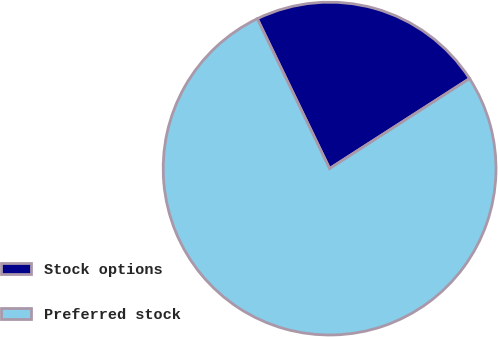Convert chart to OTSL. <chart><loc_0><loc_0><loc_500><loc_500><pie_chart><fcel>Stock options<fcel>Preferred stock<nl><fcel>23.06%<fcel>76.94%<nl></chart> 